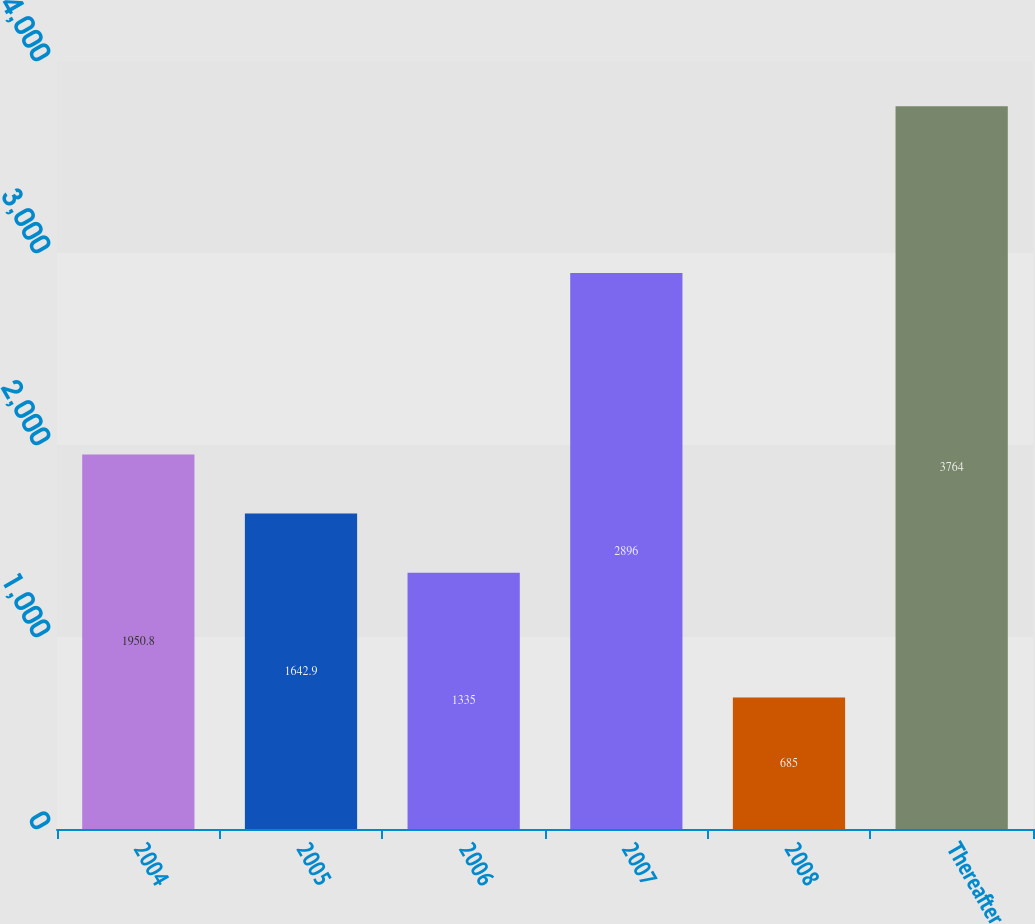Convert chart to OTSL. <chart><loc_0><loc_0><loc_500><loc_500><bar_chart><fcel>2004<fcel>2005<fcel>2006<fcel>2007<fcel>2008<fcel>Thereafter<nl><fcel>1950.8<fcel>1642.9<fcel>1335<fcel>2896<fcel>685<fcel>3764<nl></chart> 